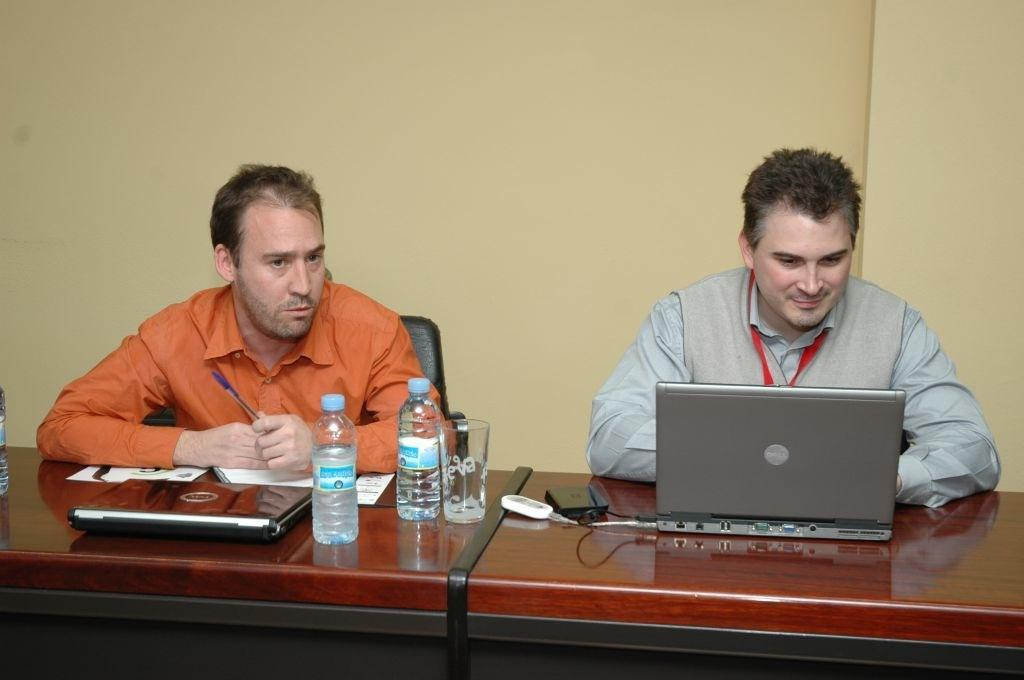How many people are sitting in the image? There are two people sitting on chairs in the image. What is the main piece of furniture in the image? There is a table in the image. What can be seen on the table? A system (likely a computer or laptop), a water bottle, and a glass are present on the table. What type of wood is used to make the snowman in the image? There is no snowman present in the image; it features two people sitting on chairs, a table, and objects on the table. 